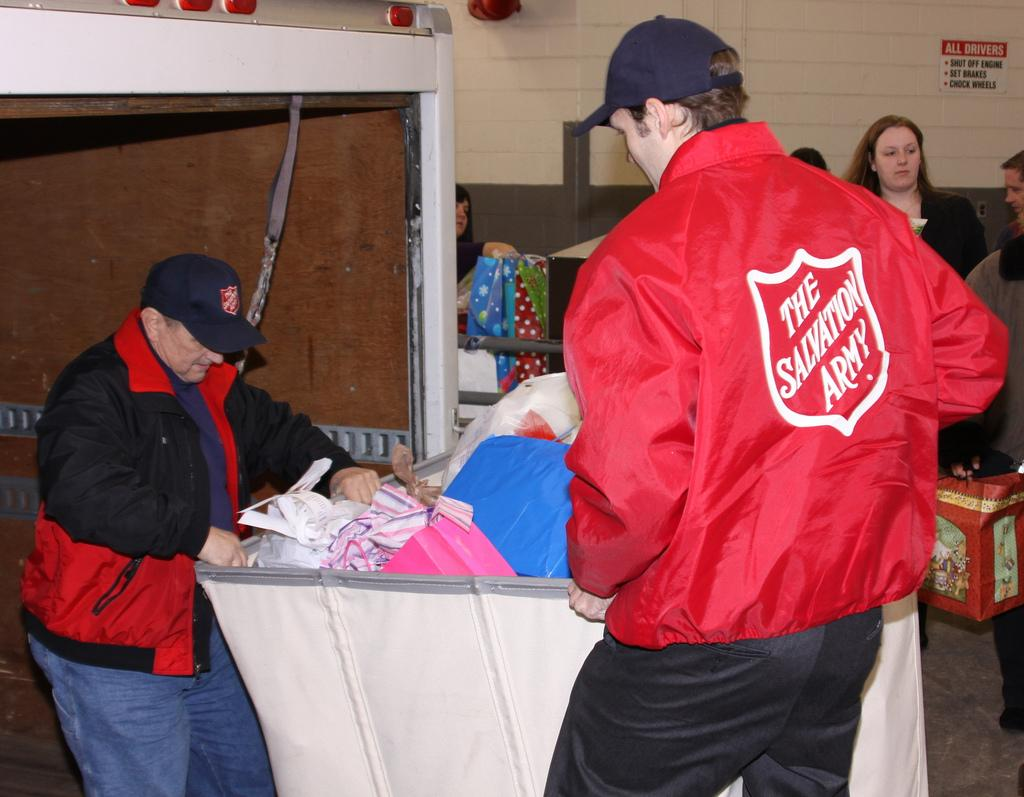<image>
Summarize the visual content of the image. A man wearing a Salvation Army jacket stands over a bin of clothing. 